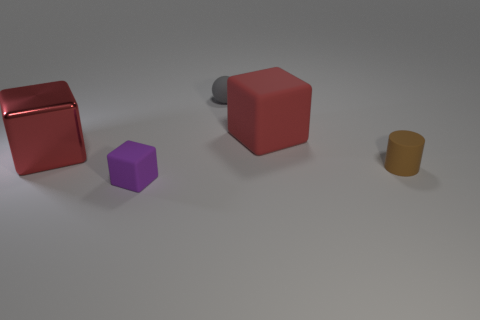Add 3 red metallic blocks. How many objects exist? 8 Subtract all cylinders. How many objects are left? 4 Add 1 tiny purple cubes. How many tiny purple cubes are left? 2 Add 1 purple rubber things. How many purple rubber things exist? 2 Subtract 0 purple cylinders. How many objects are left? 5 Subtract all tiny cyan rubber balls. Subtract all metallic blocks. How many objects are left? 4 